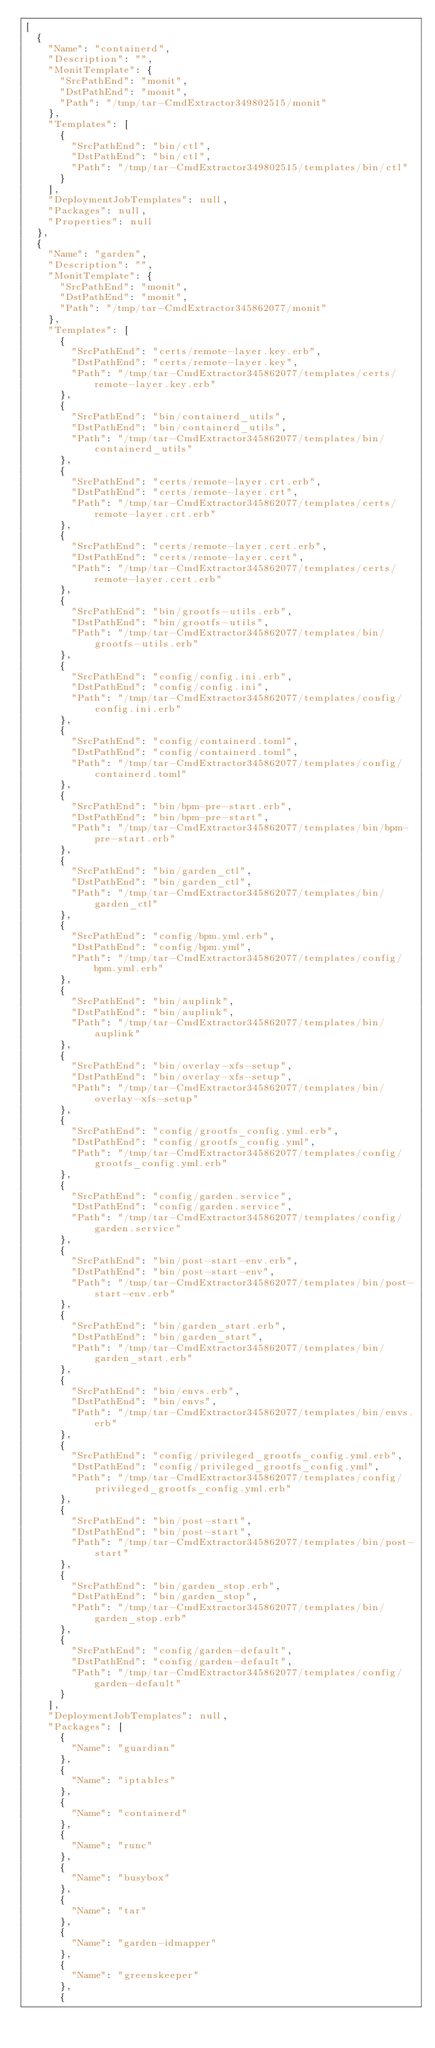Convert code to text. <code><loc_0><loc_0><loc_500><loc_500><_YAML_>[
  {
    "Name": "containerd",
    "Description": "",
    "MonitTemplate": {
      "SrcPathEnd": "monit",
      "DstPathEnd": "monit",
      "Path": "/tmp/tar-CmdExtractor349802515/monit"
    },
    "Templates": [
      {
        "SrcPathEnd": "bin/ctl",
        "DstPathEnd": "bin/ctl",
        "Path": "/tmp/tar-CmdExtractor349802515/templates/bin/ctl"
      }
    ],
    "DeploymentJobTemplates": null,
    "Packages": null,
    "Properties": null
  },
  {
    "Name": "garden",
    "Description": "",
    "MonitTemplate": {
      "SrcPathEnd": "monit",
      "DstPathEnd": "monit",
      "Path": "/tmp/tar-CmdExtractor345862077/monit"
    },
    "Templates": [
      {
        "SrcPathEnd": "certs/remote-layer.key.erb",
        "DstPathEnd": "certs/remote-layer.key",
        "Path": "/tmp/tar-CmdExtractor345862077/templates/certs/remote-layer.key.erb"
      },
      {
        "SrcPathEnd": "bin/containerd_utils",
        "DstPathEnd": "bin/containerd_utils",
        "Path": "/tmp/tar-CmdExtractor345862077/templates/bin/containerd_utils"
      },
      {
        "SrcPathEnd": "certs/remote-layer.crt.erb",
        "DstPathEnd": "certs/remote-layer.crt",
        "Path": "/tmp/tar-CmdExtractor345862077/templates/certs/remote-layer.crt.erb"
      },
      {
        "SrcPathEnd": "certs/remote-layer.cert.erb",
        "DstPathEnd": "certs/remote-layer.cert",
        "Path": "/tmp/tar-CmdExtractor345862077/templates/certs/remote-layer.cert.erb"
      },
      {
        "SrcPathEnd": "bin/grootfs-utils.erb",
        "DstPathEnd": "bin/grootfs-utils",
        "Path": "/tmp/tar-CmdExtractor345862077/templates/bin/grootfs-utils.erb"
      },
      {
        "SrcPathEnd": "config/config.ini.erb",
        "DstPathEnd": "config/config.ini",
        "Path": "/tmp/tar-CmdExtractor345862077/templates/config/config.ini.erb"
      },
      {
        "SrcPathEnd": "config/containerd.toml",
        "DstPathEnd": "config/containerd.toml",
        "Path": "/tmp/tar-CmdExtractor345862077/templates/config/containerd.toml"
      },
      {
        "SrcPathEnd": "bin/bpm-pre-start.erb",
        "DstPathEnd": "bin/bpm-pre-start",
        "Path": "/tmp/tar-CmdExtractor345862077/templates/bin/bpm-pre-start.erb"
      },
      {
        "SrcPathEnd": "bin/garden_ctl",
        "DstPathEnd": "bin/garden_ctl",
        "Path": "/tmp/tar-CmdExtractor345862077/templates/bin/garden_ctl"
      },
      {
        "SrcPathEnd": "config/bpm.yml.erb",
        "DstPathEnd": "config/bpm.yml",
        "Path": "/tmp/tar-CmdExtractor345862077/templates/config/bpm.yml.erb"
      },
      {
        "SrcPathEnd": "bin/auplink",
        "DstPathEnd": "bin/auplink",
        "Path": "/tmp/tar-CmdExtractor345862077/templates/bin/auplink"
      },
      {
        "SrcPathEnd": "bin/overlay-xfs-setup",
        "DstPathEnd": "bin/overlay-xfs-setup",
        "Path": "/tmp/tar-CmdExtractor345862077/templates/bin/overlay-xfs-setup"
      },
      {
        "SrcPathEnd": "config/grootfs_config.yml.erb",
        "DstPathEnd": "config/grootfs_config.yml",
        "Path": "/tmp/tar-CmdExtractor345862077/templates/config/grootfs_config.yml.erb"
      },
      {
        "SrcPathEnd": "config/garden.service",
        "DstPathEnd": "config/garden.service",
        "Path": "/tmp/tar-CmdExtractor345862077/templates/config/garden.service"
      },
      {
        "SrcPathEnd": "bin/post-start-env.erb",
        "DstPathEnd": "bin/post-start-env",
        "Path": "/tmp/tar-CmdExtractor345862077/templates/bin/post-start-env.erb"
      },
      {
        "SrcPathEnd": "bin/garden_start.erb",
        "DstPathEnd": "bin/garden_start",
        "Path": "/tmp/tar-CmdExtractor345862077/templates/bin/garden_start.erb"
      },
      {
        "SrcPathEnd": "bin/envs.erb",
        "DstPathEnd": "bin/envs",
        "Path": "/tmp/tar-CmdExtractor345862077/templates/bin/envs.erb"
      },
      {
        "SrcPathEnd": "config/privileged_grootfs_config.yml.erb",
        "DstPathEnd": "config/privileged_grootfs_config.yml",
        "Path": "/tmp/tar-CmdExtractor345862077/templates/config/privileged_grootfs_config.yml.erb"
      },
      {
        "SrcPathEnd": "bin/post-start",
        "DstPathEnd": "bin/post-start",
        "Path": "/tmp/tar-CmdExtractor345862077/templates/bin/post-start"
      },
      {
        "SrcPathEnd": "bin/garden_stop.erb",
        "DstPathEnd": "bin/garden_stop",
        "Path": "/tmp/tar-CmdExtractor345862077/templates/bin/garden_stop.erb"
      },
      {
        "SrcPathEnd": "config/garden-default",
        "DstPathEnd": "config/garden-default",
        "Path": "/tmp/tar-CmdExtractor345862077/templates/config/garden-default"
      }
    ],
    "DeploymentJobTemplates": null,
    "Packages": [
      {
        "Name": "guardian"
      },
      {
        "Name": "iptables"
      },
      {
        "Name": "containerd"
      },
      {
        "Name": "runc"
      },
      {
        "Name": "busybox"
      },
      {
        "Name": "tar"
      },
      {
        "Name": "garden-idmapper"
      },
      {
        "Name": "greenskeeper"
      },
      {</code> 